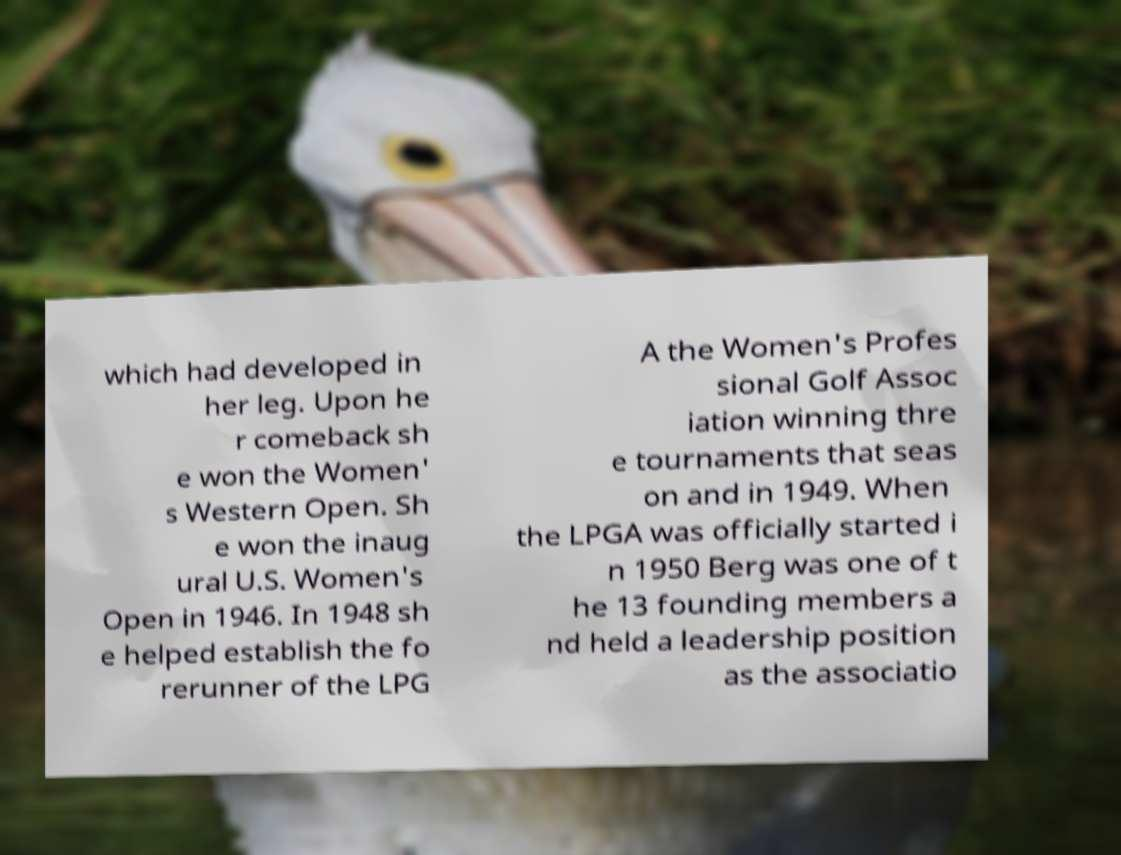What messages or text are displayed in this image? I need them in a readable, typed format. which had developed in her leg. Upon he r comeback sh e won the Women' s Western Open. Sh e won the inaug ural U.S. Women's Open in 1946. In 1948 sh e helped establish the fo rerunner of the LPG A the Women's Profes sional Golf Assoc iation winning thre e tournaments that seas on and in 1949. When the LPGA was officially started i n 1950 Berg was one of t he 13 founding members a nd held a leadership position as the associatio 